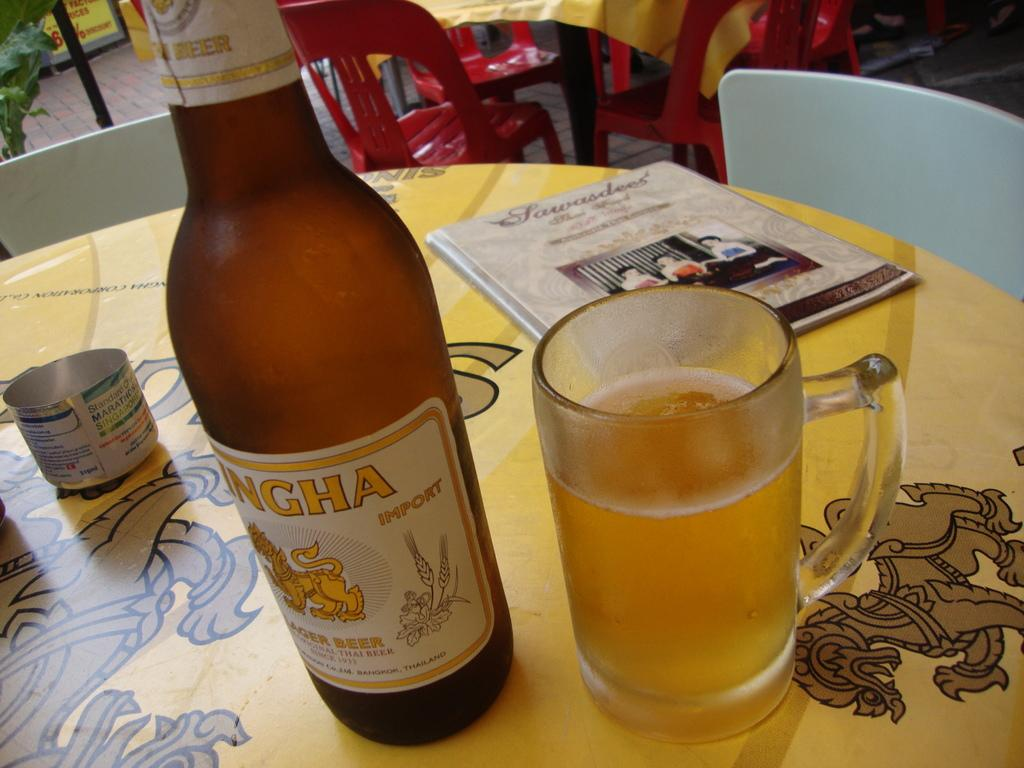<image>
Present a compact description of the photo's key features. A bottle of Ingha Import Lager Beer sits on a table next to a mug full of the beer. 